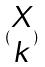Convert formula to latex. <formula><loc_0><loc_0><loc_500><loc_500>( \begin{matrix} X \\ k \end{matrix} )</formula> 